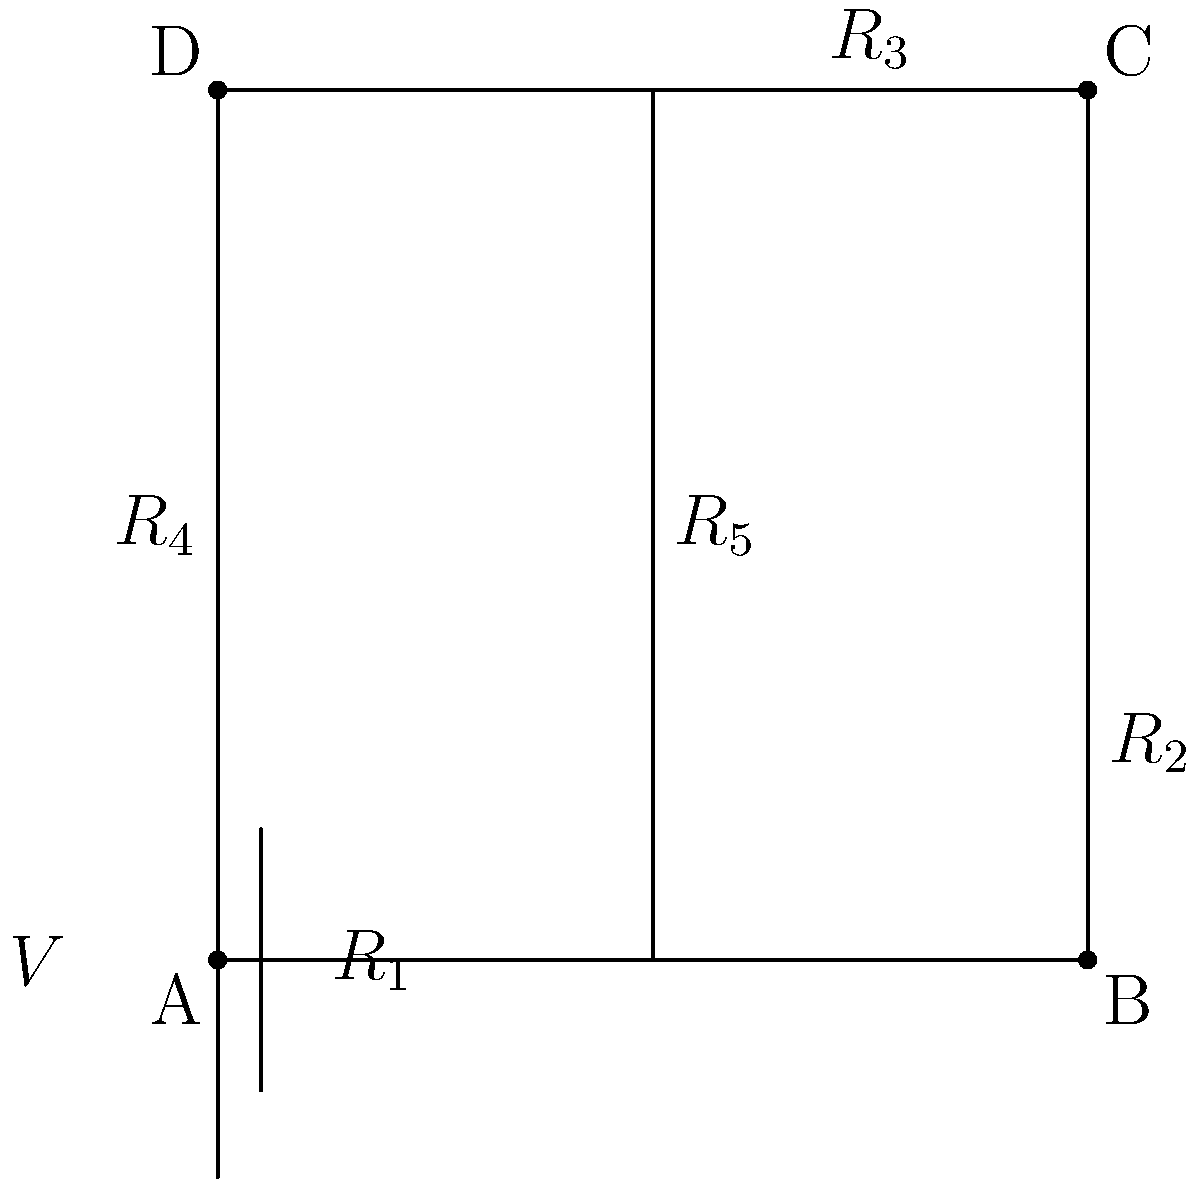In the circuit diagram shown, resistors $R_2$ and $R_5$ are connected in parallel, and this combination is in series with $R_1$, $R_3$, and $R_4$. If $R_1 = 2\Omega$, $R_2 = 6\Omega$, $R_3 = 3\Omega$, $R_4 = 1\Omega$, $R_5 = 3\Omega$, and the voltage source $V = 12V$, calculate the total current flowing through the circuit. To solve this problem, we'll follow these steps:

1) First, calculate the equivalent resistance of the parallel combination of $R_2$ and $R_5$:
   $$\frac{1}{R_{eq}} = \frac{1}{R_2} + \frac{1}{R_5} = \frac{1}{6} + \frac{1}{3} = \frac{1}{2}$$
   $$R_{eq} = 2\Omega$$

2) Now, we have a series circuit with $R_1$, $R_{eq}$, $R_3$, and $R_4$. Calculate the total resistance:
   $$R_{total} = R_1 + R_{eq} + R_3 + R_4 = 2 + 2 + 3 + 1 = 8\Omega$$

3) Use Ohm's Law to calculate the total current:
   $$I = \frac{V}{R_{total}} = \frac{12V}{8\Omega} = 1.5A$$

Therefore, the total current flowing through the circuit is 1.5A.
Answer: 1.5A 